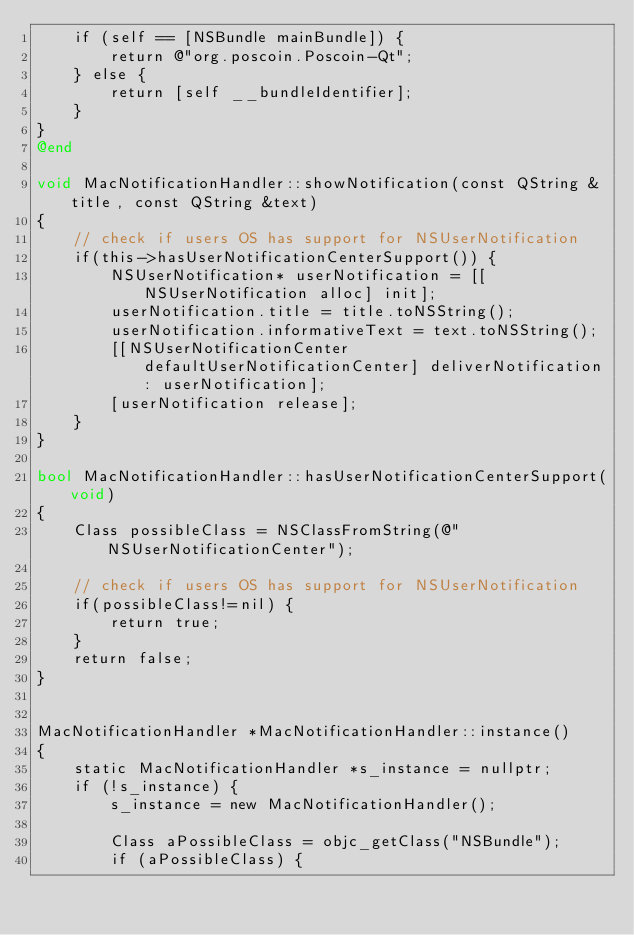<code> <loc_0><loc_0><loc_500><loc_500><_ObjectiveC_>    if (self == [NSBundle mainBundle]) {
        return @"org.poscoin.Poscoin-Qt";
    } else {
        return [self __bundleIdentifier];
    }
}
@end

void MacNotificationHandler::showNotification(const QString &title, const QString &text)
{
    // check if users OS has support for NSUserNotification
    if(this->hasUserNotificationCenterSupport()) {
        NSUserNotification* userNotification = [[NSUserNotification alloc] init];
        userNotification.title = title.toNSString();
        userNotification.informativeText = text.toNSString();
        [[NSUserNotificationCenter defaultUserNotificationCenter] deliverNotification: userNotification];
        [userNotification release];
    }
}

bool MacNotificationHandler::hasUserNotificationCenterSupport(void)
{
    Class possibleClass = NSClassFromString(@"NSUserNotificationCenter");

    // check if users OS has support for NSUserNotification
    if(possibleClass!=nil) {
        return true;
    }
    return false;
}


MacNotificationHandler *MacNotificationHandler::instance()
{
    static MacNotificationHandler *s_instance = nullptr;
    if (!s_instance) {
        s_instance = new MacNotificationHandler();

        Class aPossibleClass = objc_getClass("NSBundle");
        if (aPossibleClass) {</code> 